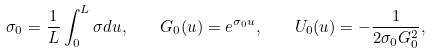<formula> <loc_0><loc_0><loc_500><loc_500>\sigma _ { 0 } = \frac { 1 } { L } \int _ { 0 } ^ { L } \sigma d u , \quad G _ { 0 } ( u ) = e ^ { \sigma _ { 0 } u } , \quad U _ { 0 } ( u ) = - \frac { 1 } { 2 \sigma _ { 0 } G _ { 0 } ^ { 2 } } ,</formula> 